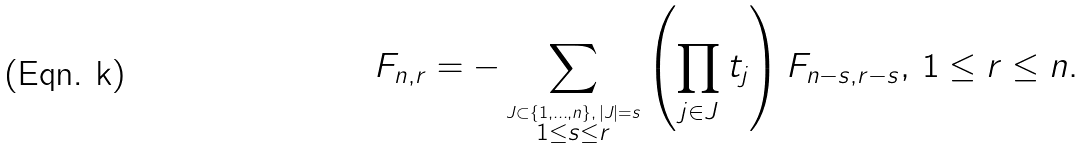<formula> <loc_0><loc_0><loc_500><loc_500>F _ { n , r } = - \sum _ { \stackrel { J \subset \{ 1 , \dots , n \} , \, | J | = s } { 1 \leq s \leq r } } \left ( \prod _ { j \in J } t _ { j } \right ) F _ { n - s , r - s } , \, 1 \leq r \leq n .</formula> 